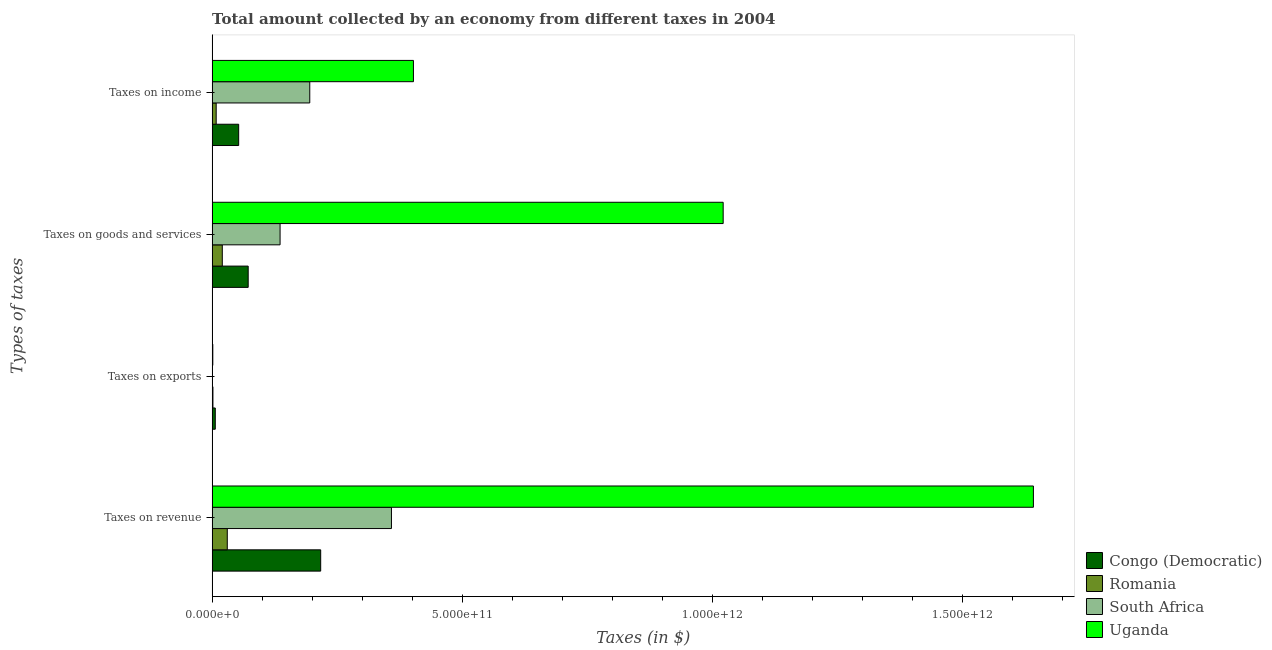How many different coloured bars are there?
Offer a very short reply. 4. How many groups of bars are there?
Ensure brevity in your answer.  4. Are the number of bars per tick equal to the number of legend labels?
Make the answer very short. Yes. Are the number of bars on each tick of the Y-axis equal?
Provide a short and direct response. Yes. What is the label of the 3rd group of bars from the top?
Offer a terse response. Taxes on exports. What is the amount collected as tax on income in Romania?
Offer a very short reply. 8.13e+09. Across all countries, what is the maximum amount collected as tax on revenue?
Your response must be concise. 1.64e+12. In which country was the amount collected as tax on goods maximum?
Your answer should be very brief. Uganda. In which country was the amount collected as tax on exports minimum?
Offer a terse response. South Africa. What is the total amount collected as tax on income in the graph?
Ensure brevity in your answer.  6.59e+11. What is the difference between the amount collected as tax on exports in Romania and that in Uganda?
Your response must be concise. 2.25e+08. What is the difference between the amount collected as tax on revenue in South Africa and the amount collected as tax on exports in Romania?
Offer a very short reply. 3.57e+11. What is the average amount collected as tax on goods per country?
Offer a very short reply. 3.13e+11. What is the difference between the amount collected as tax on goods and amount collected as tax on revenue in Uganda?
Ensure brevity in your answer.  -6.20e+11. What is the ratio of the amount collected as tax on goods in Congo (Democratic) to that in South Africa?
Provide a short and direct response. 0.53. Is the difference between the amount collected as tax on goods in Uganda and Romania greater than the difference between the amount collected as tax on revenue in Uganda and Romania?
Your response must be concise. No. What is the difference between the highest and the second highest amount collected as tax on exports?
Offer a terse response. 4.71e+09. What is the difference between the highest and the lowest amount collected as tax on exports?
Provide a short and direct response. 6.32e+09. What does the 2nd bar from the top in Taxes on exports represents?
Keep it short and to the point. South Africa. What does the 1st bar from the bottom in Taxes on goods and services represents?
Your response must be concise. Congo (Democratic). How many countries are there in the graph?
Keep it short and to the point. 4. What is the difference between two consecutive major ticks on the X-axis?
Provide a short and direct response. 5.00e+11. Does the graph contain grids?
Make the answer very short. No. What is the title of the graph?
Make the answer very short. Total amount collected by an economy from different taxes in 2004. Does "Botswana" appear as one of the legend labels in the graph?
Offer a terse response. No. What is the label or title of the X-axis?
Your answer should be very brief. Taxes (in $). What is the label or title of the Y-axis?
Your answer should be very brief. Types of taxes. What is the Taxes (in $) of Congo (Democratic) in Taxes on revenue?
Offer a terse response. 2.17e+11. What is the Taxes (in $) of Romania in Taxes on revenue?
Offer a very short reply. 3.03e+1. What is the Taxes (in $) in South Africa in Taxes on revenue?
Your answer should be very brief. 3.59e+11. What is the Taxes (in $) in Uganda in Taxes on revenue?
Provide a succinct answer. 1.64e+12. What is the Taxes (in $) in Congo (Democratic) in Taxes on exports?
Provide a succinct answer. 6.33e+09. What is the Taxes (in $) of Romania in Taxes on exports?
Provide a succinct answer. 1.62e+09. What is the Taxes (in $) of Uganda in Taxes on exports?
Provide a short and direct response. 1.39e+09. What is the Taxes (in $) in Congo (Democratic) in Taxes on goods and services?
Your response must be concise. 7.21e+1. What is the Taxes (in $) in Romania in Taxes on goods and services?
Make the answer very short. 2.03e+1. What is the Taxes (in $) of South Africa in Taxes on goods and services?
Make the answer very short. 1.36e+11. What is the Taxes (in $) of Uganda in Taxes on goods and services?
Keep it short and to the point. 1.02e+12. What is the Taxes (in $) in Congo (Democratic) in Taxes on income?
Your answer should be compact. 5.31e+1. What is the Taxes (in $) in Romania in Taxes on income?
Offer a very short reply. 8.13e+09. What is the Taxes (in $) in South Africa in Taxes on income?
Make the answer very short. 1.95e+11. What is the Taxes (in $) of Uganda in Taxes on income?
Provide a short and direct response. 4.02e+11. Across all Types of taxes, what is the maximum Taxes (in $) of Congo (Democratic)?
Your answer should be very brief. 2.17e+11. Across all Types of taxes, what is the maximum Taxes (in $) in Romania?
Provide a short and direct response. 3.03e+1. Across all Types of taxes, what is the maximum Taxes (in $) in South Africa?
Offer a very short reply. 3.59e+11. Across all Types of taxes, what is the maximum Taxes (in $) of Uganda?
Offer a very short reply. 1.64e+12. Across all Types of taxes, what is the minimum Taxes (in $) of Congo (Democratic)?
Provide a short and direct response. 6.33e+09. Across all Types of taxes, what is the minimum Taxes (in $) in Romania?
Provide a succinct answer. 1.62e+09. Across all Types of taxes, what is the minimum Taxes (in $) in South Africa?
Keep it short and to the point. 1.00e+06. Across all Types of taxes, what is the minimum Taxes (in $) in Uganda?
Your answer should be compact. 1.39e+09. What is the total Taxes (in $) in Congo (Democratic) in the graph?
Your answer should be compact. 3.49e+11. What is the total Taxes (in $) in Romania in the graph?
Give a very brief answer. 6.04e+1. What is the total Taxes (in $) of South Africa in the graph?
Keep it short and to the point. 6.90e+11. What is the total Taxes (in $) of Uganda in the graph?
Offer a terse response. 3.07e+12. What is the difference between the Taxes (in $) of Congo (Democratic) in Taxes on revenue and that in Taxes on exports?
Provide a short and direct response. 2.11e+11. What is the difference between the Taxes (in $) in Romania in Taxes on revenue and that in Taxes on exports?
Your answer should be very brief. 2.87e+1. What is the difference between the Taxes (in $) in South Africa in Taxes on revenue and that in Taxes on exports?
Your response must be concise. 3.59e+11. What is the difference between the Taxes (in $) of Uganda in Taxes on revenue and that in Taxes on exports?
Make the answer very short. 1.64e+12. What is the difference between the Taxes (in $) in Congo (Democratic) in Taxes on revenue and that in Taxes on goods and services?
Your answer should be very brief. 1.45e+11. What is the difference between the Taxes (in $) of Romania in Taxes on revenue and that in Taxes on goods and services?
Make the answer very short. 9.96e+09. What is the difference between the Taxes (in $) in South Africa in Taxes on revenue and that in Taxes on goods and services?
Provide a succinct answer. 2.23e+11. What is the difference between the Taxes (in $) of Uganda in Taxes on revenue and that in Taxes on goods and services?
Offer a very short reply. 6.20e+11. What is the difference between the Taxes (in $) of Congo (Democratic) in Taxes on revenue and that in Taxes on income?
Provide a succinct answer. 1.64e+11. What is the difference between the Taxes (in $) in Romania in Taxes on revenue and that in Taxes on income?
Provide a succinct answer. 2.22e+1. What is the difference between the Taxes (in $) of South Africa in Taxes on revenue and that in Taxes on income?
Your answer should be very brief. 1.63e+11. What is the difference between the Taxes (in $) in Uganda in Taxes on revenue and that in Taxes on income?
Your answer should be very brief. 1.24e+12. What is the difference between the Taxes (in $) of Congo (Democratic) in Taxes on exports and that in Taxes on goods and services?
Your answer should be compact. -6.58e+1. What is the difference between the Taxes (in $) of Romania in Taxes on exports and that in Taxes on goods and services?
Keep it short and to the point. -1.87e+1. What is the difference between the Taxes (in $) of South Africa in Taxes on exports and that in Taxes on goods and services?
Make the answer very short. -1.36e+11. What is the difference between the Taxes (in $) in Uganda in Taxes on exports and that in Taxes on goods and services?
Provide a short and direct response. -1.02e+12. What is the difference between the Taxes (in $) of Congo (Democratic) in Taxes on exports and that in Taxes on income?
Give a very brief answer. -4.68e+1. What is the difference between the Taxes (in $) of Romania in Taxes on exports and that in Taxes on income?
Keep it short and to the point. -6.51e+09. What is the difference between the Taxes (in $) of South Africa in Taxes on exports and that in Taxes on income?
Ensure brevity in your answer.  -1.95e+11. What is the difference between the Taxes (in $) of Uganda in Taxes on exports and that in Taxes on income?
Provide a succinct answer. -4.01e+11. What is the difference between the Taxes (in $) in Congo (Democratic) in Taxes on goods and services and that in Taxes on income?
Your answer should be very brief. 1.90e+1. What is the difference between the Taxes (in $) in Romania in Taxes on goods and services and that in Taxes on income?
Offer a very short reply. 1.22e+1. What is the difference between the Taxes (in $) of South Africa in Taxes on goods and services and that in Taxes on income?
Provide a short and direct response. -5.94e+1. What is the difference between the Taxes (in $) in Uganda in Taxes on goods and services and that in Taxes on income?
Provide a short and direct response. 6.19e+11. What is the difference between the Taxes (in $) in Congo (Democratic) in Taxes on revenue and the Taxes (in $) in Romania in Taxes on exports?
Give a very brief answer. 2.15e+11. What is the difference between the Taxes (in $) in Congo (Democratic) in Taxes on revenue and the Taxes (in $) in South Africa in Taxes on exports?
Your answer should be very brief. 2.17e+11. What is the difference between the Taxes (in $) of Congo (Democratic) in Taxes on revenue and the Taxes (in $) of Uganda in Taxes on exports?
Your answer should be very brief. 2.16e+11. What is the difference between the Taxes (in $) of Romania in Taxes on revenue and the Taxes (in $) of South Africa in Taxes on exports?
Make the answer very short. 3.03e+1. What is the difference between the Taxes (in $) in Romania in Taxes on revenue and the Taxes (in $) in Uganda in Taxes on exports?
Ensure brevity in your answer.  2.89e+1. What is the difference between the Taxes (in $) of South Africa in Taxes on revenue and the Taxes (in $) of Uganda in Taxes on exports?
Offer a very short reply. 3.57e+11. What is the difference between the Taxes (in $) in Congo (Democratic) in Taxes on revenue and the Taxes (in $) in Romania in Taxes on goods and services?
Your answer should be very brief. 1.97e+11. What is the difference between the Taxes (in $) in Congo (Democratic) in Taxes on revenue and the Taxes (in $) in South Africa in Taxes on goods and services?
Your answer should be compact. 8.12e+1. What is the difference between the Taxes (in $) of Congo (Democratic) in Taxes on revenue and the Taxes (in $) of Uganda in Taxes on goods and services?
Provide a short and direct response. -8.05e+11. What is the difference between the Taxes (in $) in Romania in Taxes on revenue and the Taxes (in $) in South Africa in Taxes on goods and services?
Your answer should be very brief. -1.06e+11. What is the difference between the Taxes (in $) in Romania in Taxes on revenue and the Taxes (in $) in Uganda in Taxes on goods and services?
Provide a short and direct response. -9.91e+11. What is the difference between the Taxes (in $) of South Africa in Taxes on revenue and the Taxes (in $) of Uganda in Taxes on goods and services?
Provide a short and direct response. -6.63e+11. What is the difference between the Taxes (in $) of Congo (Democratic) in Taxes on revenue and the Taxes (in $) of Romania in Taxes on income?
Offer a very short reply. 2.09e+11. What is the difference between the Taxes (in $) of Congo (Democratic) in Taxes on revenue and the Taxes (in $) of South Africa in Taxes on income?
Give a very brief answer. 2.18e+1. What is the difference between the Taxes (in $) in Congo (Democratic) in Taxes on revenue and the Taxes (in $) in Uganda in Taxes on income?
Make the answer very short. -1.85e+11. What is the difference between the Taxes (in $) in Romania in Taxes on revenue and the Taxes (in $) in South Africa in Taxes on income?
Your answer should be compact. -1.65e+11. What is the difference between the Taxes (in $) in Romania in Taxes on revenue and the Taxes (in $) in Uganda in Taxes on income?
Provide a short and direct response. -3.72e+11. What is the difference between the Taxes (in $) of South Africa in Taxes on revenue and the Taxes (in $) of Uganda in Taxes on income?
Give a very brief answer. -4.39e+1. What is the difference between the Taxes (in $) of Congo (Democratic) in Taxes on exports and the Taxes (in $) of Romania in Taxes on goods and services?
Keep it short and to the point. -1.40e+1. What is the difference between the Taxes (in $) in Congo (Democratic) in Taxes on exports and the Taxes (in $) in South Africa in Taxes on goods and services?
Provide a succinct answer. -1.30e+11. What is the difference between the Taxes (in $) of Congo (Democratic) in Taxes on exports and the Taxes (in $) of Uganda in Taxes on goods and services?
Give a very brief answer. -1.02e+12. What is the difference between the Taxes (in $) of Romania in Taxes on exports and the Taxes (in $) of South Africa in Taxes on goods and services?
Offer a very short reply. -1.34e+11. What is the difference between the Taxes (in $) of Romania in Taxes on exports and the Taxes (in $) of Uganda in Taxes on goods and services?
Offer a terse response. -1.02e+12. What is the difference between the Taxes (in $) in South Africa in Taxes on exports and the Taxes (in $) in Uganda in Taxes on goods and services?
Offer a very short reply. -1.02e+12. What is the difference between the Taxes (in $) in Congo (Democratic) in Taxes on exports and the Taxes (in $) in Romania in Taxes on income?
Ensure brevity in your answer.  -1.80e+09. What is the difference between the Taxes (in $) in Congo (Democratic) in Taxes on exports and the Taxes (in $) in South Africa in Taxes on income?
Offer a terse response. -1.89e+11. What is the difference between the Taxes (in $) in Congo (Democratic) in Taxes on exports and the Taxes (in $) in Uganda in Taxes on income?
Your answer should be compact. -3.96e+11. What is the difference between the Taxes (in $) in Romania in Taxes on exports and the Taxes (in $) in South Africa in Taxes on income?
Make the answer very short. -1.94e+11. What is the difference between the Taxes (in $) in Romania in Taxes on exports and the Taxes (in $) in Uganda in Taxes on income?
Your response must be concise. -4.01e+11. What is the difference between the Taxes (in $) in South Africa in Taxes on exports and the Taxes (in $) in Uganda in Taxes on income?
Provide a succinct answer. -4.02e+11. What is the difference between the Taxes (in $) of Congo (Democratic) in Taxes on goods and services and the Taxes (in $) of Romania in Taxes on income?
Ensure brevity in your answer.  6.40e+1. What is the difference between the Taxes (in $) in Congo (Democratic) in Taxes on goods and services and the Taxes (in $) in South Africa in Taxes on income?
Your answer should be very brief. -1.23e+11. What is the difference between the Taxes (in $) in Congo (Democratic) in Taxes on goods and services and the Taxes (in $) in Uganda in Taxes on income?
Provide a succinct answer. -3.30e+11. What is the difference between the Taxes (in $) of Romania in Taxes on goods and services and the Taxes (in $) of South Africa in Taxes on income?
Provide a short and direct response. -1.75e+11. What is the difference between the Taxes (in $) in Romania in Taxes on goods and services and the Taxes (in $) in Uganda in Taxes on income?
Offer a terse response. -3.82e+11. What is the difference between the Taxes (in $) of South Africa in Taxes on goods and services and the Taxes (in $) of Uganda in Taxes on income?
Offer a terse response. -2.67e+11. What is the average Taxes (in $) in Congo (Democratic) per Types of taxes?
Provide a succinct answer. 8.71e+1. What is the average Taxes (in $) of Romania per Types of taxes?
Give a very brief answer. 1.51e+1. What is the average Taxes (in $) in South Africa per Types of taxes?
Provide a succinct answer. 1.72e+11. What is the average Taxes (in $) in Uganda per Types of taxes?
Ensure brevity in your answer.  7.67e+11. What is the difference between the Taxes (in $) of Congo (Democratic) and Taxes (in $) of Romania in Taxes on revenue?
Provide a succinct answer. 1.87e+11. What is the difference between the Taxes (in $) of Congo (Democratic) and Taxes (in $) of South Africa in Taxes on revenue?
Keep it short and to the point. -1.41e+11. What is the difference between the Taxes (in $) in Congo (Democratic) and Taxes (in $) in Uganda in Taxes on revenue?
Give a very brief answer. -1.42e+12. What is the difference between the Taxes (in $) in Romania and Taxes (in $) in South Africa in Taxes on revenue?
Provide a short and direct response. -3.28e+11. What is the difference between the Taxes (in $) in Romania and Taxes (in $) in Uganda in Taxes on revenue?
Make the answer very short. -1.61e+12. What is the difference between the Taxes (in $) of South Africa and Taxes (in $) of Uganda in Taxes on revenue?
Your answer should be compact. -1.28e+12. What is the difference between the Taxes (in $) in Congo (Democratic) and Taxes (in $) in Romania in Taxes on exports?
Offer a terse response. 4.71e+09. What is the difference between the Taxes (in $) of Congo (Democratic) and Taxes (in $) of South Africa in Taxes on exports?
Your answer should be compact. 6.32e+09. What is the difference between the Taxes (in $) of Congo (Democratic) and Taxes (in $) of Uganda in Taxes on exports?
Keep it short and to the point. 4.94e+09. What is the difference between the Taxes (in $) in Romania and Taxes (in $) in South Africa in Taxes on exports?
Your response must be concise. 1.61e+09. What is the difference between the Taxes (in $) of Romania and Taxes (in $) of Uganda in Taxes on exports?
Your answer should be compact. 2.25e+08. What is the difference between the Taxes (in $) of South Africa and Taxes (in $) of Uganda in Taxes on exports?
Your answer should be very brief. -1.39e+09. What is the difference between the Taxes (in $) in Congo (Democratic) and Taxes (in $) in Romania in Taxes on goods and services?
Ensure brevity in your answer.  5.18e+1. What is the difference between the Taxes (in $) of Congo (Democratic) and Taxes (in $) of South Africa in Taxes on goods and services?
Your answer should be compact. -6.38e+1. What is the difference between the Taxes (in $) in Congo (Democratic) and Taxes (in $) in Uganda in Taxes on goods and services?
Make the answer very short. -9.50e+11. What is the difference between the Taxes (in $) of Romania and Taxes (in $) of South Africa in Taxes on goods and services?
Ensure brevity in your answer.  -1.16e+11. What is the difference between the Taxes (in $) of Romania and Taxes (in $) of Uganda in Taxes on goods and services?
Offer a very short reply. -1.00e+12. What is the difference between the Taxes (in $) of South Africa and Taxes (in $) of Uganda in Taxes on goods and services?
Offer a very short reply. -8.86e+11. What is the difference between the Taxes (in $) of Congo (Democratic) and Taxes (in $) of Romania in Taxes on income?
Your answer should be very brief. 4.49e+1. What is the difference between the Taxes (in $) in Congo (Democratic) and Taxes (in $) in South Africa in Taxes on income?
Your answer should be very brief. -1.42e+11. What is the difference between the Taxes (in $) of Congo (Democratic) and Taxes (in $) of Uganda in Taxes on income?
Your answer should be very brief. -3.49e+11. What is the difference between the Taxes (in $) of Romania and Taxes (in $) of South Africa in Taxes on income?
Your answer should be very brief. -1.87e+11. What is the difference between the Taxes (in $) in Romania and Taxes (in $) in Uganda in Taxes on income?
Offer a very short reply. -3.94e+11. What is the difference between the Taxes (in $) of South Africa and Taxes (in $) of Uganda in Taxes on income?
Offer a very short reply. -2.07e+11. What is the ratio of the Taxes (in $) of Congo (Democratic) in Taxes on revenue to that in Taxes on exports?
Offer a very short reply. 34.32. What is the ratio of the Taxes (in $) of Romania in Taxes on revenue to that in Taxes on exports?
Provide a short and direct response. 18.76. What is the ratio of the Taxes (in $) of South Africa in Taxes on revenue to that in Taxes on exports?
Provide a succinct answer. 3.59e+05. What is the ratio of the Taxes (in $) of Uganda in Taxes on revenue to that in Taxes on exports?
Keep it short and to the point. 1181.29. What is the ratio of the Taxes (in $) in Congo (Democratic) in Taxes on revenue to that in Taxes on goods and services?
Offer a terse response. 3.01. What is the ratio of the Taxes (in $) in Romania in Taxes on revenue to that in Taxes on goods and services?
Keep it short and to the point. 1.49. What is the ratio of the Taxes (in $) of South Africa in Taxes on revenue to that in Taxes on goods and services?
Provide a short and direct response. 2.64. What is the ratio of the Taxes (in $) in Uganda in Taxes on revenue to that in Taxes on goods and services?
Provide a succinct answer. 1.61. What is the ratio of the Taxes (in $) in Congo (Democratic) in Taxes on revenue to that in Taxes on income?
Make the answer very short. 4.09. What is the ratio of the Taxes (in $) of Romania in Taxes on revenue to that in Taxes on income?
Provide a short and direct response. 3.73. What is the ratio of the Taxes (in $) of South Africa in Taxes on revenue to that in Taxes on income?
Ensure brevity in your answer.  1.84. What is the ratio of the Taxes (in $) in Uganda in Taxes on revenue to that in Taxes on income?
Provide a succinct answer. 4.08. What is the ratio of the Taxes (in $) of Congo (Democratic) in Taxes on exports to that in Taxes on goods and services?
Your answer should be very brief. 0.09. What is the ratio of the Taxes (in $) in Romania in Taxes on exports to that in Taxes on goods and services?
Keep it short and to the point. 0.08. What is the ratio of the Taxes (in $) of Uganda in Taxes on exports to that in Taxes on goods and services?
Provide a succinct answer. 0. What is the ratio of the Taxes (in $) in Congo (Democratic) in Taxes on exports to that in Taxes on income?
Keep it short and to the point. 0.12. What is the ratio of the Taxes (in $) of Romania in Taxes on exports to that in Taxes on income?
Offer a very short reply. 0.2. What is the ratio of the Taxes (in $) of Uganda in Taxes on exports to that in Taxes on income?
Your response must be concise. 0. What is the ratio of the Taxes (in $) in Congo (Democratic) in Taxes on goods and services to that in Taxes on income?
Provide a short and direct response. 1.36. What is the ratio of the Taxes (in $) in Romania in Taxes on goods and services to that in Taxes on income?
Make the answer very short. 2.5. What is the ratio of the Taxes (in $) of South Africa in Taxes on goods and services to that in Taxes on income?
Ensure brevity in your answer.  0.7. What is the ratio of the Taxes (in $) of Uganda in Taxes on goods and services to that in Taxes on income?
Offer a terse response. 2.54. What is the difference between the highest and the second highest Taxes (in $) in Congo (Democratic)?
Provide a short and direct response. 1.45e+11. What is the difference between the highest and the second highest Taxes (in $) in Romania?
Give a very brief answer. 9.96e+09. What is the difference between the highest and the second highest Taxes (in $) of South Africa?
Offer a terse response. 1.63e+11. What is the difference between the highest and the second highest Taxes (in $) in Uganda?
Your answer should be very brief. 6.20e+11. What is the difference between the highest and the lowest Taxes (in $) in Congo (Democratic)?
Offer a terse response. 2.11e+11. What is the difference between the highest and the lowest Taxes (in $) in Romania?
Give a very brief answer. 2.87e+1. What is the difference between the highest and the lowest Taxes (in $) in South Africa?
Give a very brief answer. 3.59e+11. What is the difference between the highest and the lowest Taxes (in $) in Uganda?
Offer a terse response. 1.64e+12. 